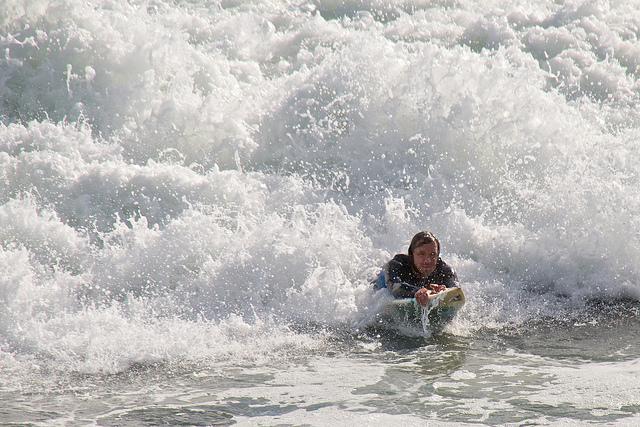Is this person wet?
Be succinct. Yes. Is the water calm or rapid?
Keep it brief. Rapid. What is this person riding?
Concise answer only. Surfboard. 